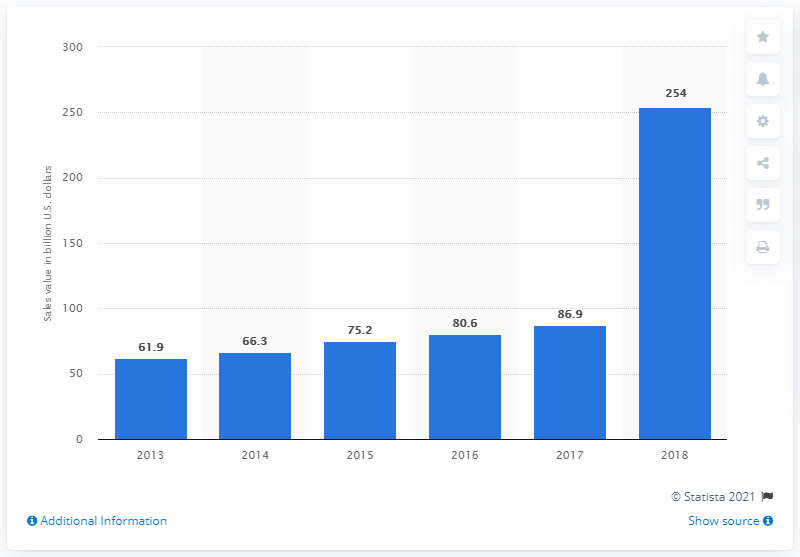Point out several critical features in this image. The revenue from smartphone sales in the region was approximately 254 million from 2013 to 2018. 